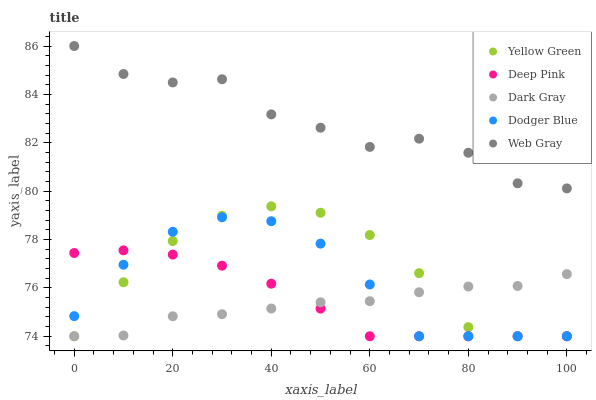Does Dark Gray have the minimum area under the curve?
Answer yes or no. Yes. Does Web Gray have the maximum area under the curve?
Answer yes or no. Yes. Does Deep Pink have the minimum area under the curve?
Answer yes or no. No. Does Deep Pink have the maximum area under the curve?
Answer yes or no. No. Is Deep Pink the smoothest?
Answer yes or no. Yes. Is Web Gray the roughest?
Answer yes or no. Yes. Is Dodger Blue the smoothest?
Answer yes or no. No. Is Dodger Blue the roughest?
Answer yes or no. No. Does Dark Gray have the lowest value?
Answer yes or no. Yes. Does Web Gray have the lowest value?
Answer yes or no. No. Does Web Gray have the highest value?
Answer yes or no. Yes. Does Deep Pink have the highest value?
Answer yes or no. No. Is Deep Pink less than Web Gray?
Answer yes or no. Yes. Is Web Gray greater than Dodger Blue?
Answer yes or no. Yes. Does Yellow Green intersect Deep Pink?
Answer yes or no. Yes. Is Yellow Green less than Deep Pink?
Answer yes or no. No. Is Yellow Green greater than Deep Pink?
Answer yes or no. No. Does Deep Pink intersect Web Gray?
Answer yes or no. No. 